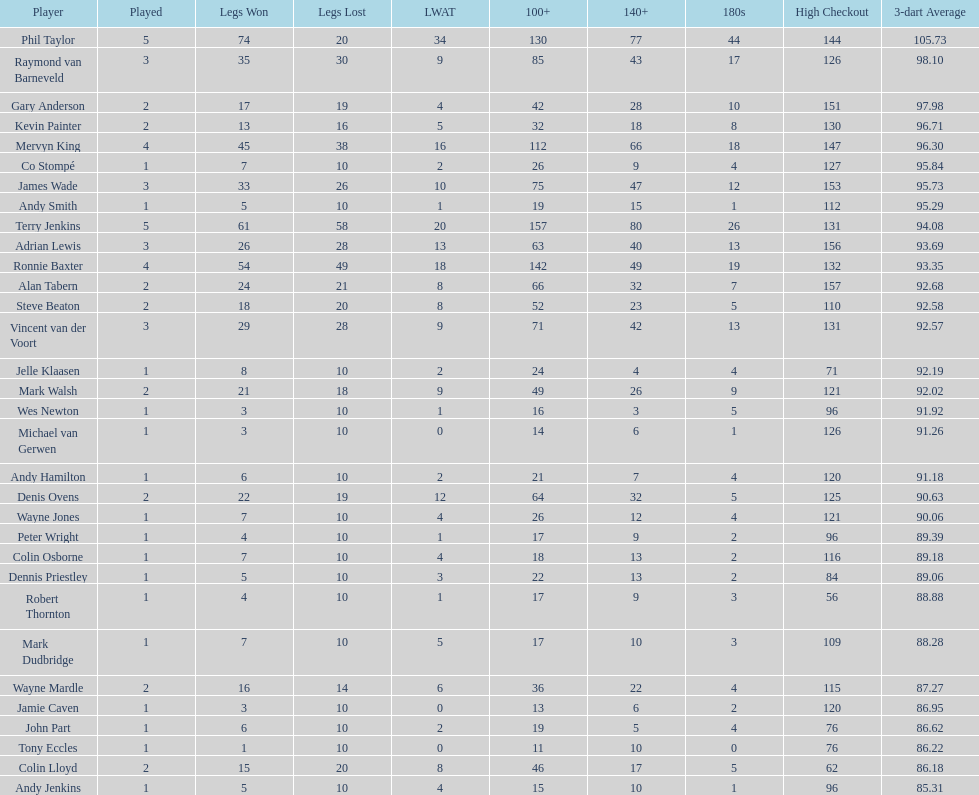What were the total number of legs won by ronnie baxter? 54. 